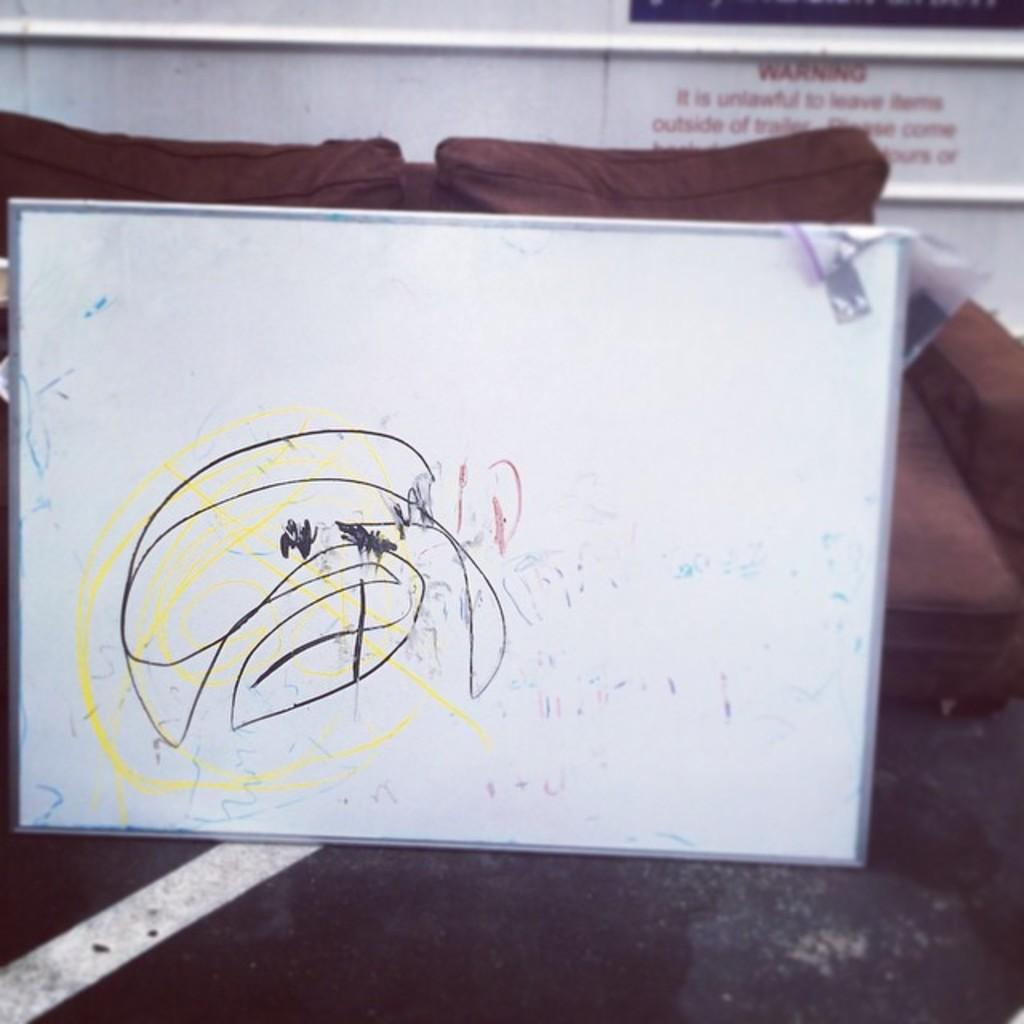What is the main object in the image? There is a whiteboard in the image. What is on the whiteboard? There is writing on the whiteboard. What can be seen in the background of the image? There is a signboard in the background of the image. What type of title can be seen on the train passing by in the image? There is no train present in the image, so there is no title to be seen. 